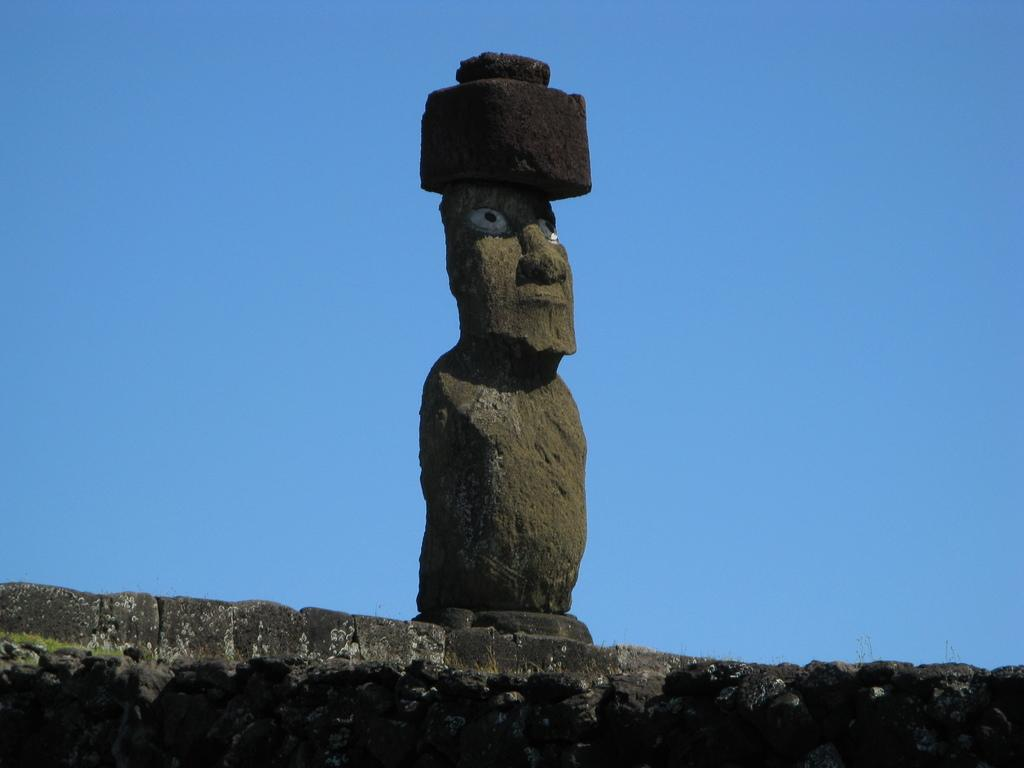What can be seen in the background of the image? There is a clear blue sky in the background of the image. What is visible in the foreground of the image? There is a wall visible in the image. What is on the wall in the image? A sculpture is present on the wall. What type of soap is being used to clean the sculpture in the image? There is no soap or cleaning activity present in the image; the sculpture is simply on the wall. 